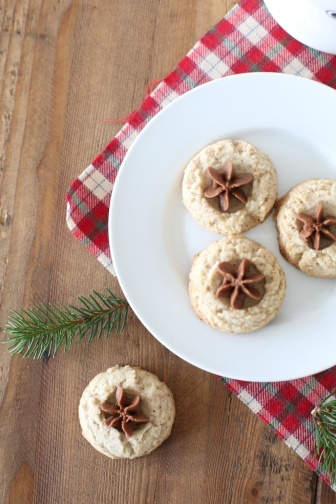Please describe the different elements present in this image in greater detail. The central focus of the image is a clean white plate that displays three delicately baked sugar cookies. Each cookie is adorned with a whole star anise, creating an aromatic and visually appealing garnish. The cookies are placed on a red and white checkered napkin, which spreads out to one side, adding a rustic and homey touch to the scene. To the right of the plate, a fourth cookie lies on the wooden surface. This cookie matches those on the plate, also topped with a star anise. Adding a dash of natural beauty, a sprig of dark green foliage is positioned next to the solitary cookie, contributing to the festive ambiance of the setting. The overall composition suggests a comforting and celebratory environment, likely intended to invoke the warmth and joy of the holiday season. Can you come up with a short story inspired by this scene? In a cozy little cottage nestled in the heart of a snowy forest, Grandma Lucy prepared for the annual holiday gathering. She lovingly baked her famous sugar cookies, each sprinkled with a touch of magic—a star anise, to remind everyone of the wonder of the season. With the cookies laid out on a bright red and white checkered napkin, she added a fresh sprig of pine for a touch of nature, knowing how it would bring a smile to her grandchildren's faces. As they arrived, the aroma of cookies and the charm of her meticulous arrangement greeted them, wrapping them in the warmth of cherished traditions and the joy of family togetherness. 